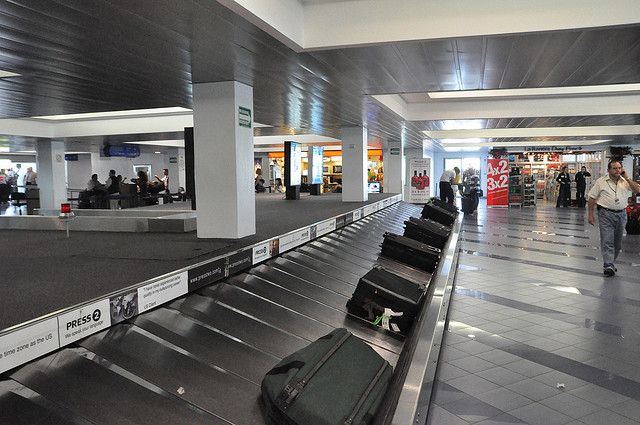Extract all visible text content from this image. PRESS 3x2 2 